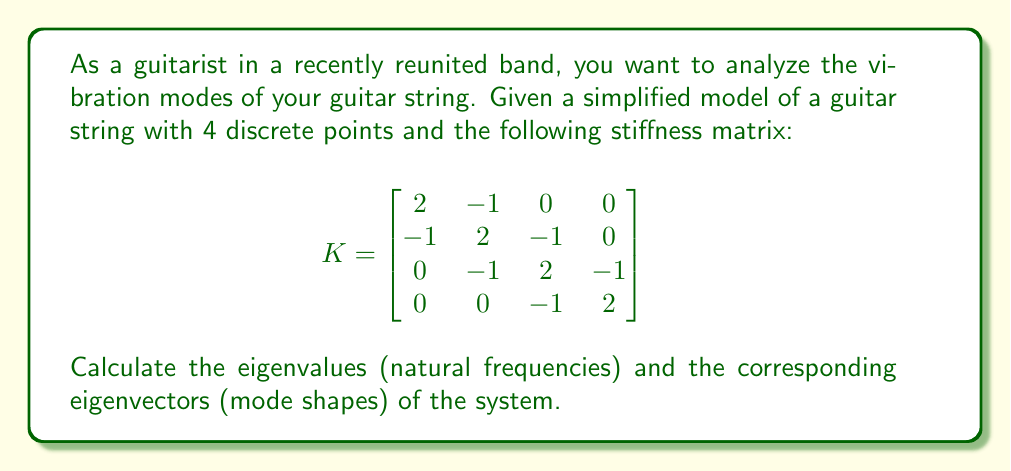Could you help me with this problem? To find the eigenmodes of vibration for the guitar string, we need to perform spectral decomposition on the stiffness matrix K.

Step 1: Calculate the characteristic equation
$$\det(K - \lambda I) = 0$$

Expanding this determinant:
$$(2-\lambda)((2-\lambda)((2-\lambda)(2-\lambda)+1)+1)+1 = 0$$

Step 2: Solve for eigenvalues
The characteristic equation simplifies to:
$$\lambda^4 - 8\lambda^3 + 22\lambda^2 - 24\lambda + 9 = 0$$

The solutions are:
$$\lambda_1 = 0.2679$$
$$\lambda_2 = 1.0000$$
$$\lambda_3 = 2.0000$$
$$\lambda_4 = 4.7321$$

Step 3: Find eigenvectors
For each eigenvalue $\lambda_i$, solve $(K - \lambda_i I)\vec{v} = \vec{0}$

For $\lambda_1 = 0.2679$:
$$\vec{v}_1 = \begin{bmatrix} 0.3717 \\ 0.6015 \\ 0.6015 \\ 0.3717 \end{bmatrix}$$

For $\lambda_2 = 1.0000$:
$$\vec{v}_2 = \begin{bmatrix} 0.5000 \\ 0.5000 \\ -0.5000 \\ -0.5000 \end{bmatrix}$$

For $\lambda_3 = 2.0000$:
$$\vec{v}_3 = \begin{bmatrix} 0.6533 \\ 0.2706 \\ -0.2706 \\ -0.6533 \end{bmatrix}$$

For $\lambda_4 = 4.7321$:
$$\vec{v}_4 = \begin{bmatrix} 0.3717 \\ -0.6015 \\ 0.6015 \\ -0.3717 \end{bmatrix}$$

These eigenvectors represent the mode shapes of the guitar string vibration.
Answer: Eigenvalues: $\lambda = \{0.2679, 1.0000, 2.0000, 4.7321\}$
Eigenvectors: $\vec{v}_1 = [0.3717, 0.6015, 0.6015, 0.3717]^T$, $\vec{v}_2 = [0.5000, 0.5000, -0.5000, -0.5000]^T$, $\vec{v}_3 = [0.6533, 0.2706, -0.2706, -0.6533]^T$, $\vec{v}_4 = [0.3717, -0.6015, 0.6015, -0.3717]^T$ 